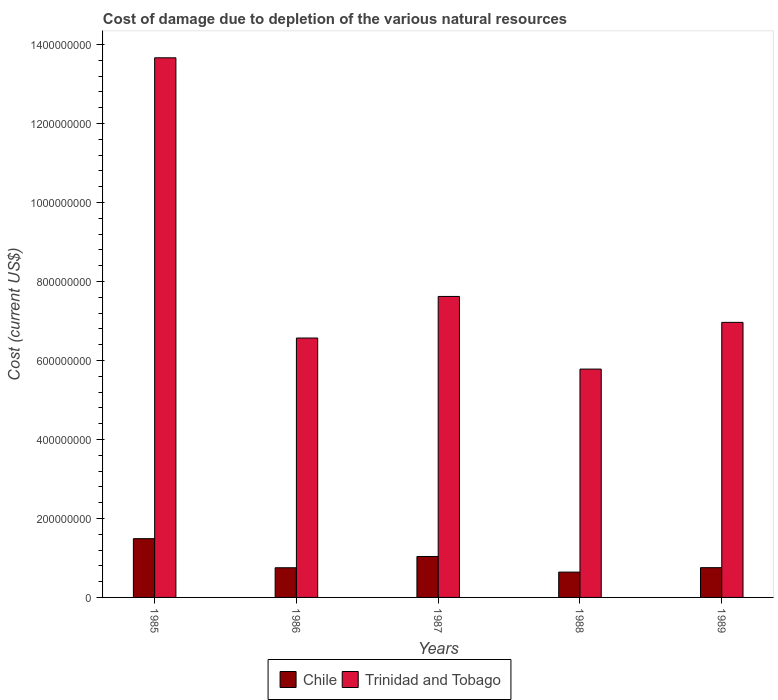How many different coloured bars are there?
Give a very brief answer. 2. How many groups of bars are there?
Offer a terse response. 5. Are the number of bars on each tick of the X-axis equal?
Provide a short and direct response. Yes. What is the label of the 4th group of bars from the left?
Offer a very short reply. 1988. In how many cases, is the number of bars for a given year not equal to the number of legend labels?
Provide a succinct answer. 0. What is the cost of damage caused due to the depletion of various natural resources in Trinidad and Tobago in 1989?
Ensure brevity in your answer.  6.97e+08. Across all years, what is the maximum cost of damage caused due to the depletion of various natural resources in Trinidad and Tobago?
Ensure brevity in your answer.  1.37e+09. Across all years, what is the minimum cost of damage caused due to the depletion of various natural resources in Trinidad and Tobago?
Make the answer very short. 5.78e+08. In which year was the cost of damage caused due to the depletion of various natural resources in Chile maximum?
Make the answer very short. 1985. What is the total cost of damage caused due to the depletion of various natural resources in Trinidad and Tobago in the graph?
Keep it short and to the point. 4.06e+09. What is the difference between the cost of damage caused due to the depletion of various natural resources in Chile in 1985 and that in 1989?
Your response must be concise. 7.34e+07. What is the difference between the cost of damage caused due to the depletion of various natural resources in Chile in 1988 and the cost of damage caused due to the depletion of various natural resources in Trinidad and Tobago in 1986?
Your response must be concise. -5.93e+08. What is the average cost of damage caused due to the depletion of various natural resources in Trinidad and Tobago per year?
Your answer should be compact. 8.12e+08. In the year 1988, what is the difference between the cost of damage caused due to the depletion of various natural resources in Chile and cost of damage caused due to the depletion of various natural resources in Trinidad and Tobago?
Ensure brevity in your answer.  -5.14e+08. What is the ratio of the cost of damage caused due to the depletion of various natural resources in Chile in 1986 to that in 1989?
Provide a short and direct response. 1. What is the difference between the highest and the second highest cost of damage caused due to the depletion of various natural resources in Trinidad and Tobago?
Give a very brief answer. 6.04e+08. What is the difference between the highest and the lowest cost of damage caused due to the depletion of various natural resources in Trinidad and Tobago?
Keep it short and to the point. 7.88e+08. Is the sum of the cost of damage caused due to the depletion of various natural resources in Trinidad and Tobago in 1988 and 1989 greater than the maximum cost of damage caused due to the depletion of various natural resources in Chile across all years?
Offer a terse response. Yes. What does the 1st bar from the right in 1989 represents?
Give a very brief answer. Trinidad and Tobago. Are all the bars in the graph horizontal?
Provide a short and direct response. No. Does the graph contain grids?
Keep it short and to the point. No. How many legend labels are there?
Your answer should be very brief. 2. What is the title of the graph?
Make the answer very short. Cost of damage due to depletion of the various natural resources. What is the label or title of the X-axis?
Keep it short and to the point. Years. What is the label or title of the Y-axis?
Offer a very short reply. Cost (current US$). What is the Cost (current US$) in Chile in 1985?
Your answer should be very brief. 1.49e+08. What is the Cost (current US$) in Trinidad and Tobago in 1985?
Offer a terse response. 1.37e+09. What is the Cost (current US$) of Chile in 1986?
Make the answer very short. 7.51e+07. What is the Cost (current US$) in Trinidad and Tobago in 1986?
Give a very brief answer. 6.57e+08. What is the Cost (current US$) in Chile in 1987?
Make the answer very short. 1.04e+08. What is the Cost (current US$) of Trinidad and Tobago in 1987?
Offer a very short reply. 7.62e+08. What is the Cost (current US$) of Chile in 1988?
Make the answer very short. 6.41e+07. What is the Cost (current US$) in Trinidad and Tobago in 1988?
Make the answer very short. 5.78e+08. What is the Cost (current US$) of Chile in 1989?
Your response must be concise. 7.54e+07. What is the Cost (current US$) of Trinidad and Tobago in 1989?
Make the answer very short. 6.97e+08. Across all years, what is the maximum Cost (current US$) of Chile?
Give a very brief answer. 1.49e+08. Across all years, what is the maximum Cost (current US$) of Trinidad and Tobago?
Your answer should be very brief. 1.37e+09. Across all years, what is the minimum Cost (current US$) in Chile?
Your answer should be compact. 6.41e+07. Across all years, what is the minimum Cost (current US$) in Trinidad and Tobago?
Give a very brief answer. 5.78e+08. What is the total Cost (current US$) in Chile in the graph?
Your response must be concise. 4.67e+08. What is the total Cost (current US$) in Trinidad and Tobago in the graph?
Your answer should be very brief. 4.06e+09. What is the difference between the Cost (current US$) of Chile in 1985 and that in 1986?
Your response must be concise. 7.37e+07. What is the difference between the Cost (current US$) of Trinidad and Tobago in 1985 and that in 1986?
Make the answer very short. 7.10e+08. What is the difference between the Cost (current US$) in Chile in 1985 and that in 1987?
Offer a terse response. 4.51e+07. What is the difference between the Cost (current US$) in Trinidad and Tobago in 1985 and that in 1987?
Your response must be concise. 6.04e+08. What is the difference between the Cost (current US$) of Chile in 1985 and that in 1988?
Give a very brief answer. 8.47e+07. What is the difference between the Cost (current US$) of Trinidad and Tobago in 1985 and that in 1988?
Provide a succinct answer. 7.88e+08. What is the difference between the Cost (current US$) of Chile in 1985 and that in 1989?
Your response must be concise. 7.34e+07. What is the difference between the Cost (current US$) in Trinidad and Tobago in 1985 and that in 1989?
Provide a succinct answer. 6.70e+08. What is the difference between the Cost (current US$) of Chile in 1986 and that in 1987?
Make the answer very short. -2.86e+07. What is the difference between the Cost (current US$) in Trinidad and Tobago in 1986 and that in 1987?
Your answer should be compact. -1.05e+08. What is the difference between the Cost (current US$) in Chile in 1986 and that in 1988?
Provide a short and direct response. 1.10e+07. What is the difference between the Cost (current US$) of Trinidad and Tobago in 1986 and that in 1988?
Give a very brief answer. 7.87e+07. What is the difference between the Cost (current US$) in Chile in 1986 and that in 1989?
Ensure brevity in your answer.  -2.67e+05. What is the difference between the Cost (current US$) of Trinidad and Tobago in 1986 and that in 1989?
Offer a very short reply. -3.97e+07. What is the difference between the Cost (current US$) of Chile in 1987 and that in 1988?
Your response must be concise. 3.96e+07. What is the difference between the Cost (current US$) of Trinidad and Tobago in 1987 and that in 1988?
Give a very brief answer. 1.84e+08. What is the difference between the Cost (current US$) in Chile in 1987 and that in 1989?
Your answer should be compact. 2.83e+07. What is the difference between the Cost (current US$) of Trinidad and Tobago in 1987 and that in 1989?
Give a very brief answer. 6.56e+07. What is the difference between the Cost (current US$) of Chile in 1988 and that in 1989?
Keep it short and to the point. -1.13e+07. What is the difference between the Cost (current US$) of Trinidad and Tobago in 1988 and that in 1989?
Make the answer very short. -1.18e+08. What is the difference between the Cost (current US$) in Chile in 1985 and the Cost (current US$) in Trinidad and Tobago in 1986?
Offer a terse response. -5.08e+08. What is the difference between the Cost (current US$) of Chile in 1985 and the Cost (current US$) of Trinidad and Tobago in 1987?
Ensure brevity in your answer.  -6.13e+08. What is the difference between the Cost (current US$) of Chile in 1985 and the Cost (current US$) of Trinidad and Tobago in 1988?
Provide a short and direct response. -4.29e+08. What is the difference between the Cost (current US$) in Chile in 1985 and the Cost (current US$) in Trinidad and Tobago in 1989?
Provide a short and direct response. -5.48e+08. What is the difference between the Cost (current US$) in Chile in 1986 and the Cost (current US$) in Trinidad and Tobago in 1987?
Provide a short and direct response. -6.87e+08. What is the difference between the Cost (current US$) of Chile in 1986 and the Cost (current US$) of Trinidad and Tobago in 1988?
Your response must be concise. -5.03e+08. What is the difference between the Cost (current US$) in Chile in 1986 and the Cost (current US$) in Trinidad and Tobago in 1989?
Provide a short and direct response. -6.21e+08. What is the difference between the Cost (current US$) in Chile in 1987 and the Cost (current US$) in Trinidad and Tobago in 1988?
Provide a succinct answer. -4.75e+08. What is the difference between the Cost (current US$) of Chile in 1987 and the Cost (current US$) of Trinidad and Tobago in 1989?
Provide a succinct answer. -5.93e+08. What is the difference between the Cost (current US$) of Chile in 1988 and the Cost (current US$) of Trinidad and Tobago in 1989?
Provide a short and direct response. -6.32e+08. What is the average Cost (current US$) of Chile per year?
Provide a short and direct response. 9.34e+07. What is the average Cost (current US$) of Trinidad and Tobago per year?
Keep it short and to the point. 8.12e+08. In the year 1985, what is the difference between the Cost (current US$) in Chile and Cost (current US$) in Trinidad and Tobago?
Ensure brevity in your answer.  -1.22e+09. In the year 1986, what is the difference between the Cost (current US$) of Chile and Cost (current US$) of Trinidad and Tobago?
Give a very brief answer. -5.82e+08. In the year 1987, what is the difference between the Cost (current US$) of Chile and Cost (current US$) of Trinidad and Tobago?
Ensure brevity in your answer.  -6.59e+08. In the year 1988, what is the difference between the Cost (current US$) in Chile and Cost (current US$) in Trinidad and Tobago?
Provide a short and direct response. -5.14e+08. In the year 1989, what is the difference between the Cost (current US$) in Chile and Cost (current US$) in Trinidad and Tobago?
Offer a very short reply. -6.21e+08. What is the ratio of the Cost (current US$) in Chile in 1985 to that in 1986?
Provide a short and direct response. 1.98. What is the ratio of the Cost (current US$) in Trinidad and Tobago in 1985 to that in 1986?
Your response must be concise. 2.08. What is the ratio of the Cost (current US$) in Chile in 1985 to that in 1987?
Offer a terse response. 1.44. What is the ratio of the Cost (current US$) of Trinidad and Tobago in 1985 to that in 1987?
Keep it short and to the point. 1.79. What is the ratio of the Cost (current US$) in Chile in 1985 to that in 1988?
Make the answer very short. 2.32. What is the ratio of the Cost (current US$) in Trinidad and Tobago in 1985 to that in 1988?
Provide a short and direct response. 2.36. What is the ratio of the Cost (current US$) in Chile in 1985 to that in 1989?
Provide a short and direct response. 1.97. What is the ratio of the Cost (current US$) of Trinidad and Tobago in 1985 to that in 1989?
Your response must be concise. 1.96. What is the ratio of the Cost (current US$) in Chile in 1986 to that in 1987?
Offer a very short reply. 0.72. What is the ratio of the Cost (current US$) of Trinidad and Tobago in 1986 to that in 1987?
Your answer should be very brief. 0.86. What is the ratio of the Cost (current US$) of Chile in 1986 to that in 1988?
Offer a very short reply. 1.17. What is the ratio of the Cost (current US$) in Trinidad and Tobago in 1986 to that in 1988?
Make the answer very short. 1.14. What is the ratio of the Cost (current US$) of Chile in 1986 to that in 1989?
Your response must be concise. 1. What is the ratio of the Cost (current US$) of Trinidad and Tobago in 1986 to that in 1989?
Keep it short and to the point. 0.94. What is the ratio of the Cost (current US$) in Chile in 1987 to that in 1988?
Offer a terse response. 1.62. What is the ratio of the Cost (current US$) of Trinidad and Tobago in 1987 to that in 1988?
Provide a succinct answer. 1.32. What is the ratio of the Cost (current US$) in Chile in 1987 to that in 1989?
Ensure brevity in your answer.  1.38. What is the ratio of the Cost (current US$) of Trinidad and Tobago in 1987 to that in 1989?
Your answer should be compact. 1.09. What is the ratio of the Cost (current US$) in Chile in 1988 to that in 1989?
Offer a very short reply. 0.85. What is the ratio of the Cost (current US$) in Trinidad and Tobago in 1988 to that in 1989?
Your answer should be compact. 0.83. What is the difference between the highest and the second highest Cost (current US$) of Chile?
Make the answer very short. 4.51e+07. What is the difference between the highest and the second highest Cost (current US$) in Trinidad and Tobago?
Provide a short and direct response. 6.04e+08. What is the difference between the highest and the lowest Cost (current US$) in Chile?
Ensure brevity in your answer.  8.47e+07. What is the difference between the highest and the lowest Cost (current US$) in Trinidad and Tobago?
Give a very brief answer. 7.88e+08. 